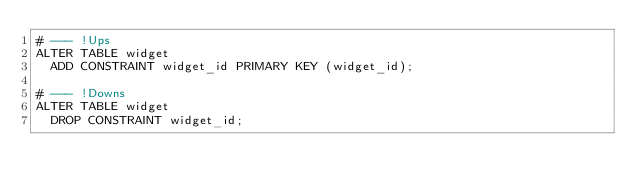<code> <loc_0><loc_0><loc_500><loc_500><_SQL_># --- !Ups
ALTER TABLE widget
  ADD CONSTRAINT widget_id PRIMARY KEY (widget_id);
  
# --- !Downs
ALTER TABLE widget
  DROP CONSTRAINT widget_id;</code> 